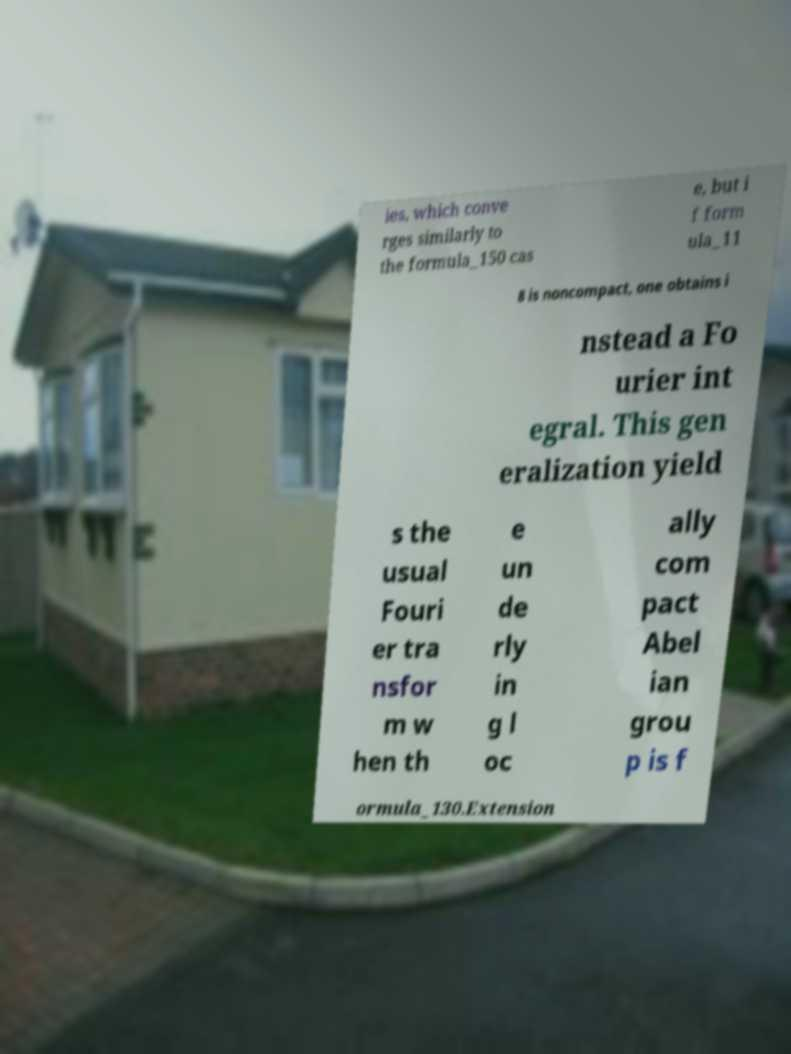Please identify and transcribe the text found in this image. ies, which conve rges similarly to the formula_150 cas e, but i f form ula_11 8 is noncompact, one obtains i nstead a Fo urier int egral. This gen eralization yield s the usual Fouri er tra nsfor m w hen th e un de rly in g l oc ally com pact Abel ian grou p is f ormula_130.Extension 